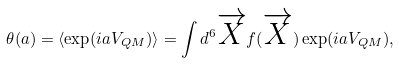<formula> <loc_0><loc_0><loc_500><loc_500>\theta ( a ) = \langle \exp ( i a V _ { Q M } ) \rangle = \int d ^ { 6 } \overrightarrow { X } f ( \overrightarrow { X } ) \exp ( i a V _ { Q M } ) ,</formula> 